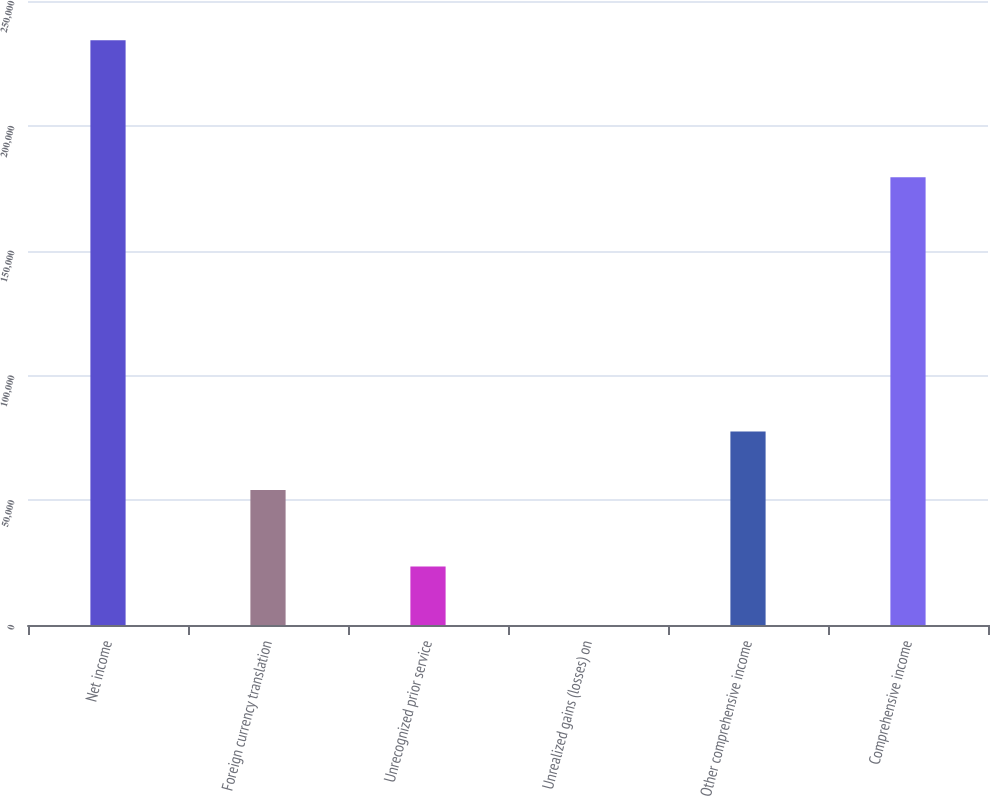Convert chart to OTSL. <chart><loc_0><loc_0><loc_500><loc_500><bar_chart><fcel>Net income<fcel>Foreign currency translation<fcel>Unrecognized prior service<fcel>Unrealized gains (losses) on<fcel>Other comprehensive income<fcel>Comprehensive income<nl><fcel>234299<fcel>54077<fcel>23458.7<fcel>32<fcel>77503.7<fcel>179394<nl></chart> 